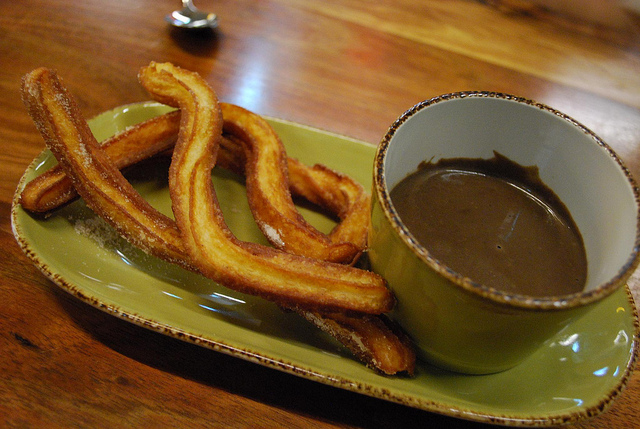What color is the plate? The plate is green, creating a pleasing visual appeal with the churros and chocolate. 